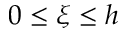Convert formula to latex. <formula><loc_0><loc_0><loc_500><loc_500>0 \leq \xi \leq h</formula> 